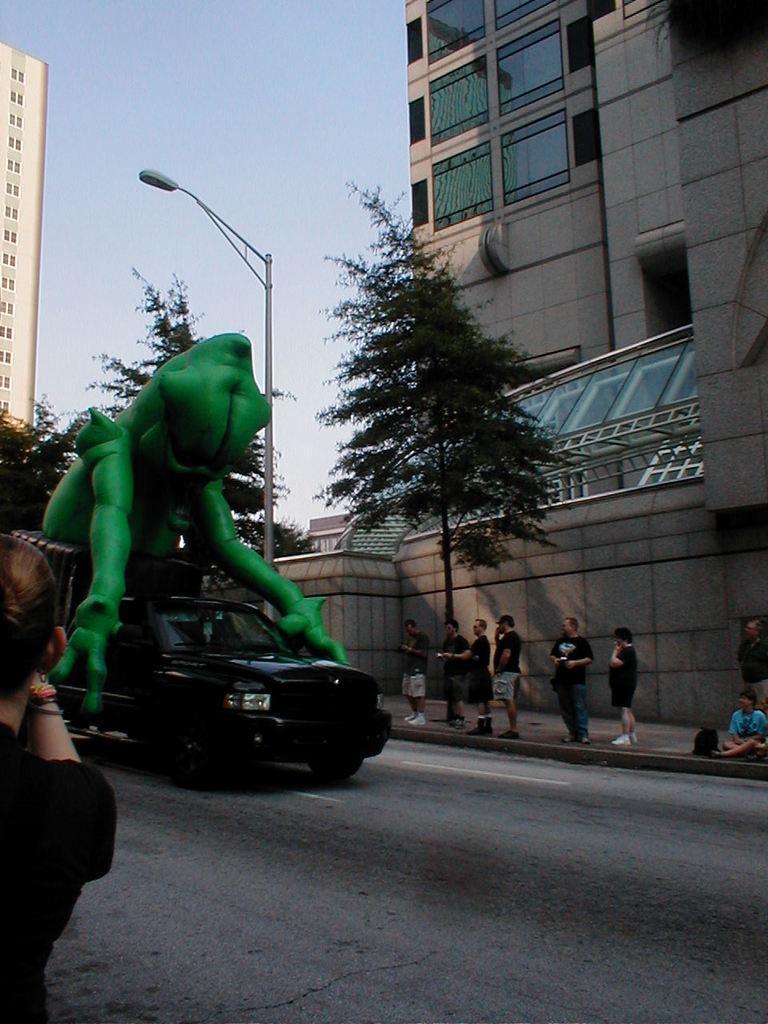How would you summarize this image in a sentence or two? In this picture there is a green color statue which is placed on the black color car. On the right I can see some people who are standing near to the road. In the back I can see the trees and buildings. Beside the car there is a street light. At the top I can see the sky. In the bottom left there is a woman who is wearing black dress. 